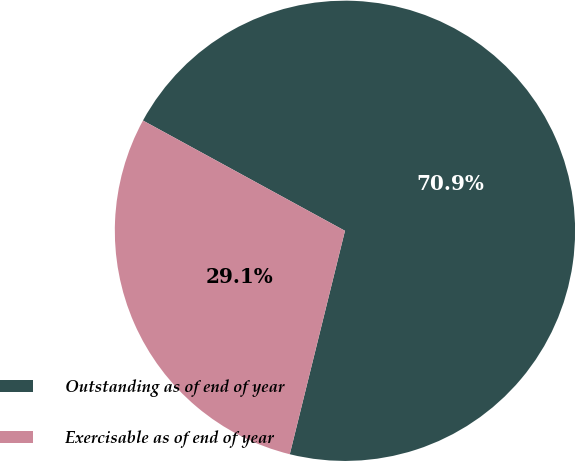Convert chart to OTSL. <chart><loc_0><loc_0><loc_500><loc_500><pie_chart><fcel>Outstanding as of end of year<fcel>Exercisable as of end of year<nl><fcel>70.9%<fcel>29.1%<nl></chart> 